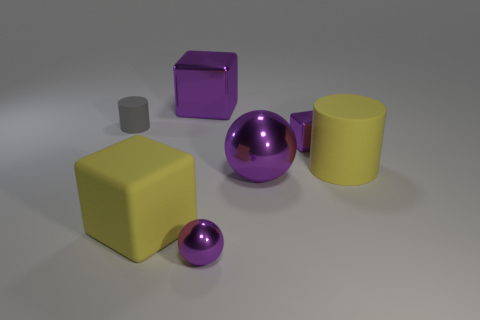Add 1 big yellow objects. How many objects exist? 8 Subtract all blocks. How many objects are left? 4 Add 4 small purple things. How many small purple things are left? 6 Add 1 large purple objects. How many large purple objects exist? 3 Subtract 0 blue balls. How many objects are left? 7 Subtract all matte things. Subtract all yellow things. How many objects are left? 2 